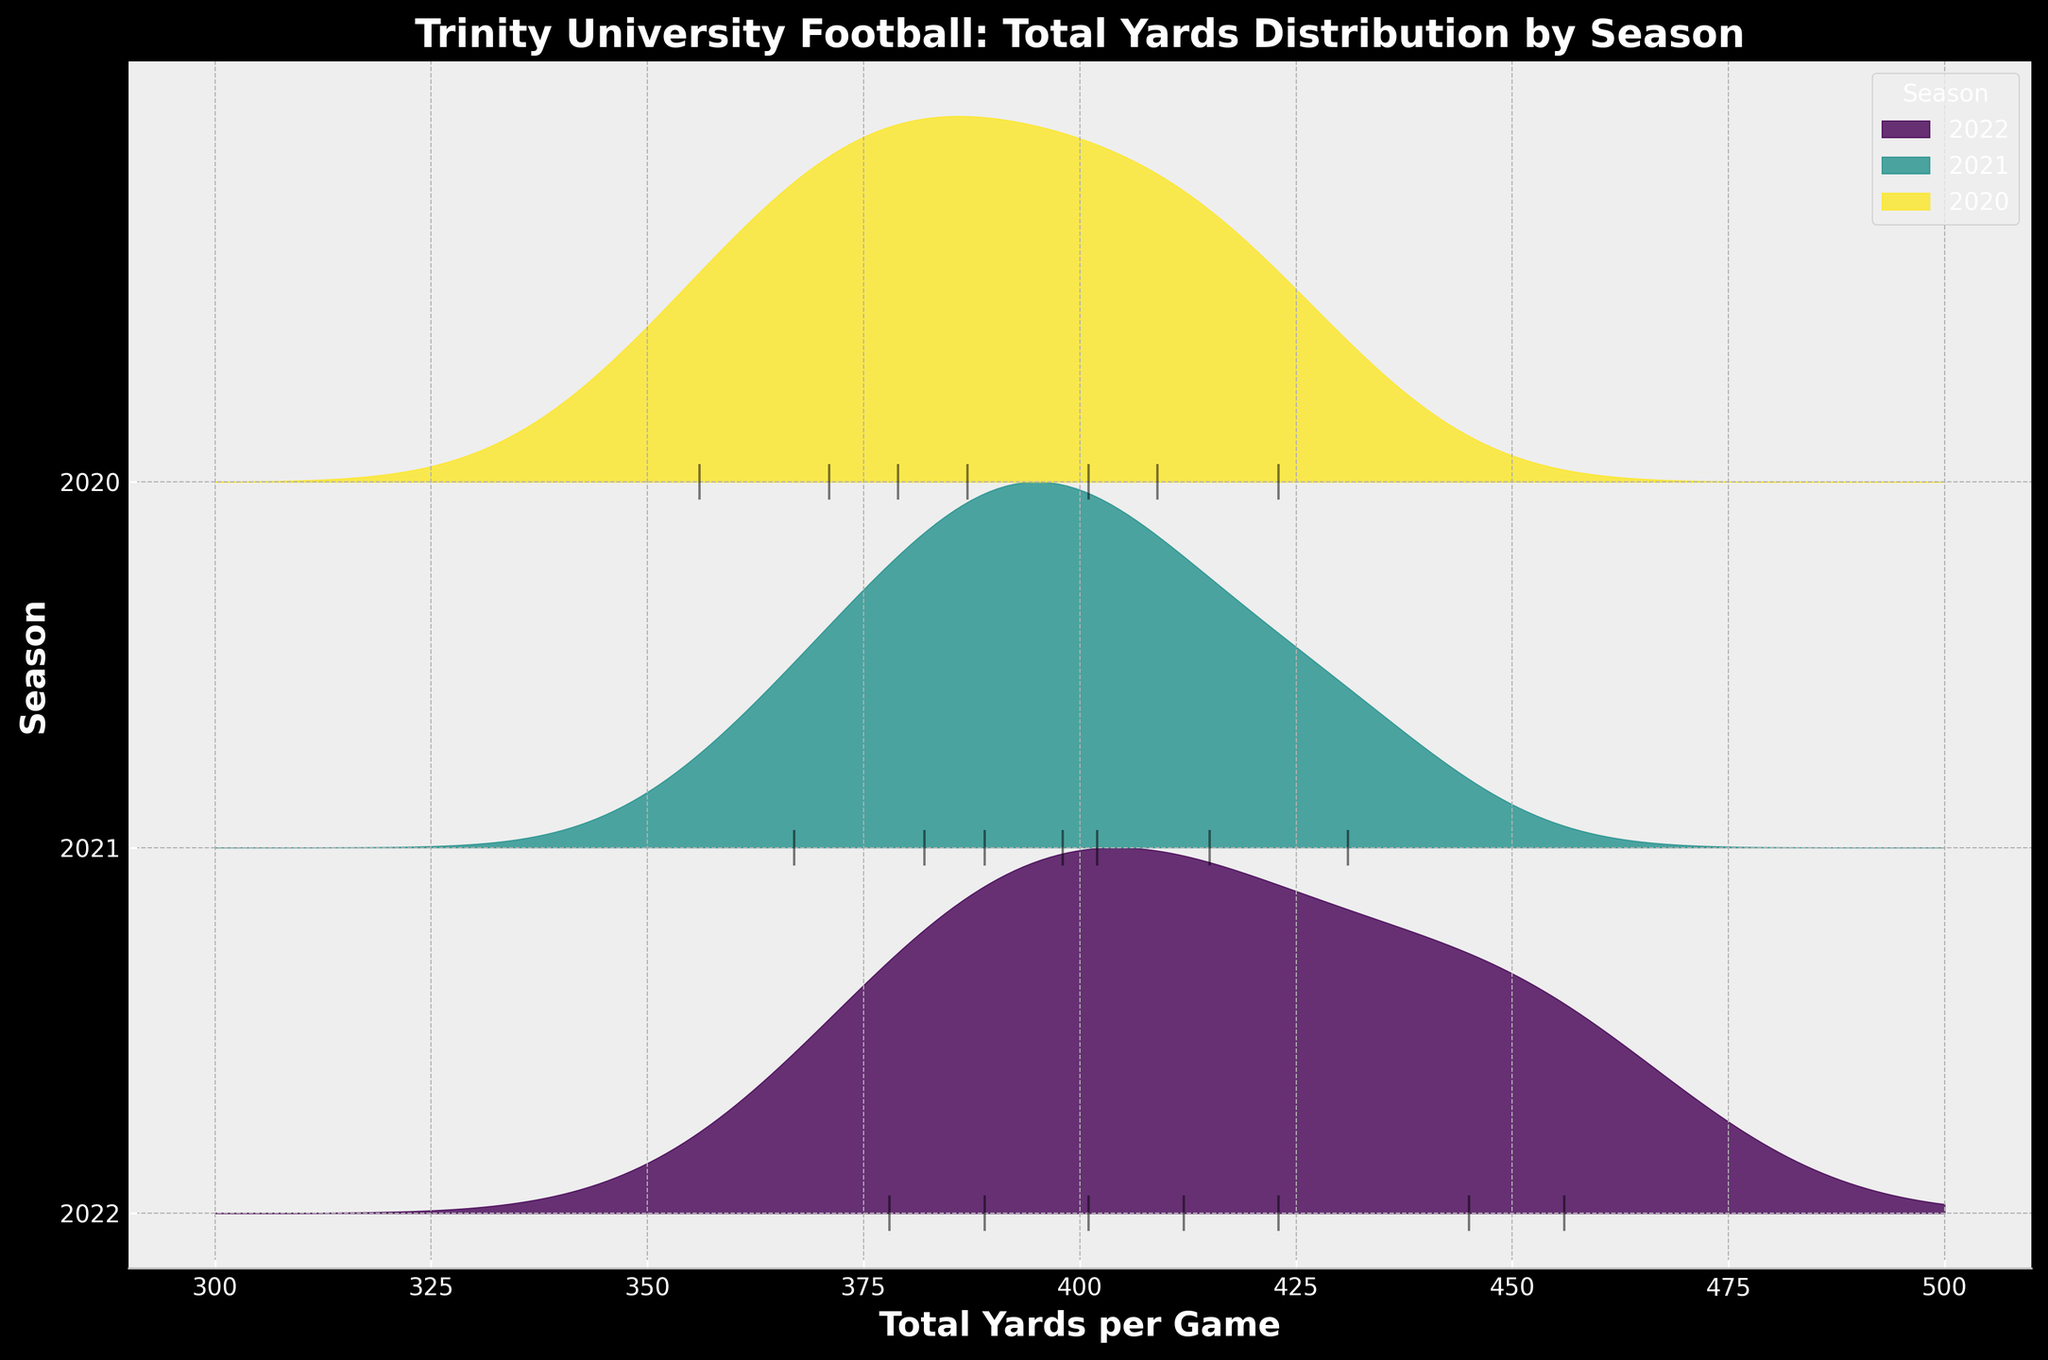What is the title of the plot? The title is prominently displayed at the top of the plot and indicates what the figure is about.
Answer: "Trinity University Football: Total Yards Distribution by Season" How many seasons are compared in the figure? By looking at the distinct y-ticks and the labels associated with each, you can count the number of seasons.
Answer: Three Which season has the highest peak density of total yards gained per game? Observing the curves, identify the season with the peak that extends the highest on the y-axis relative to its baseline.
Answer: 2022 Are the total yards per game more spread out in 2020 or 2021? Compare the spread of the density curves for 2020 and 2021. The season with a wider curve indicates more variability.
Answer: 2020 What is the range of total yards per game covered by the x-axis? Look at the x-axis from the leftmost point to the rightmost point to determine the range.
Answer: 300 to 500 Which season has the least variation in total yards gained per game? The season with the narrowest density curve indicates the least variation.
Answer: 2021 Between which two consecutive seasons did the average total yards per game increase the most? Estimate the central tendency of the density curves for each season and compare the changes between consecutive seasons.
Answer: 2021 to 2022 Do any of the seasons have outliers, and if so, which ones? Outliers can be identified as isolated ticks far away from the main density curve.
Answer: Yes, 2022 Which season appears to have the highest median total yards per game? By examining the density curves, the median would lie around the center of the peak of the curve. Identify the curve with the highest center peak.
Answer: 2022 Which season has the most games with total yards greater than 400? Count the number of tick marks above the 400 mark on the x-axis for each season.
Answer: 2022 